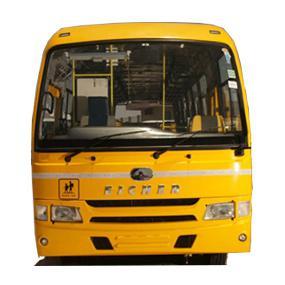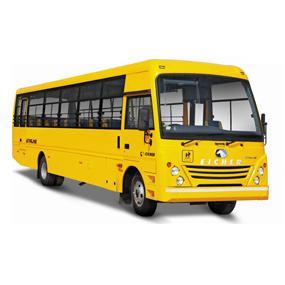The first image is the image on the left, the second image is the image on the right. Evaluate the accuracy of this statement regarding the images: "Each image shows a single yellow bus with a nearly flat front, and the bus on the right is displayed at an angle but does not have a black stripe visible on its side.". Is it true? Answer yes or no. Yes. The first image is the image on the left, the second image is the image on the right. For the images displayed, is the sentence "there is a yellow school bus with a flat front and the stop sign visible" factually correct? Answer yes or no. No. 